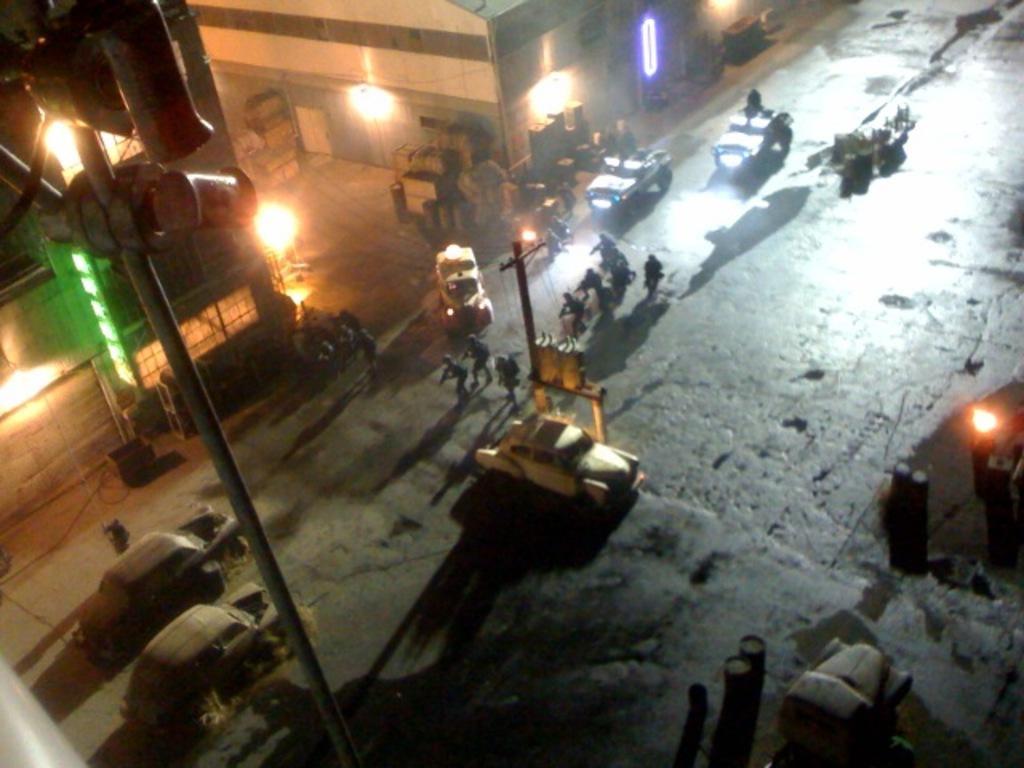Describe this image in one or two sentences. This picture is clicked outside. In the center we can see the group of people and the cars running the road and we can see the lights, metal rod and some other items. In the background we can see the buildings. 